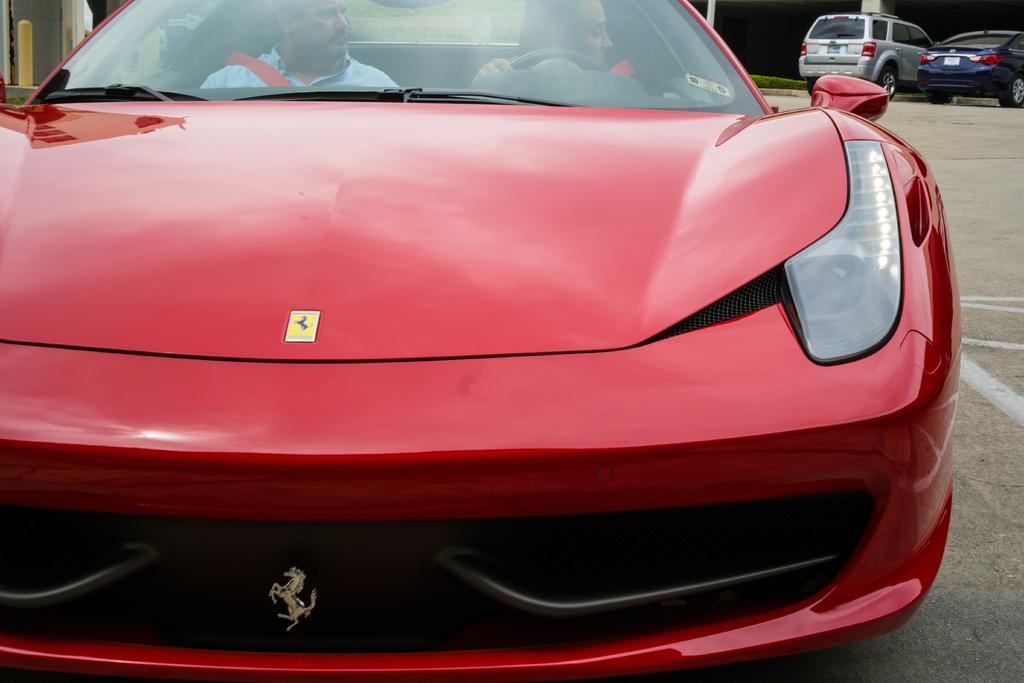Could you give a brief overview of what you see in this image? In this image we can see a few cars on the road, there are two persons sitting in a red car, there is a grass. 